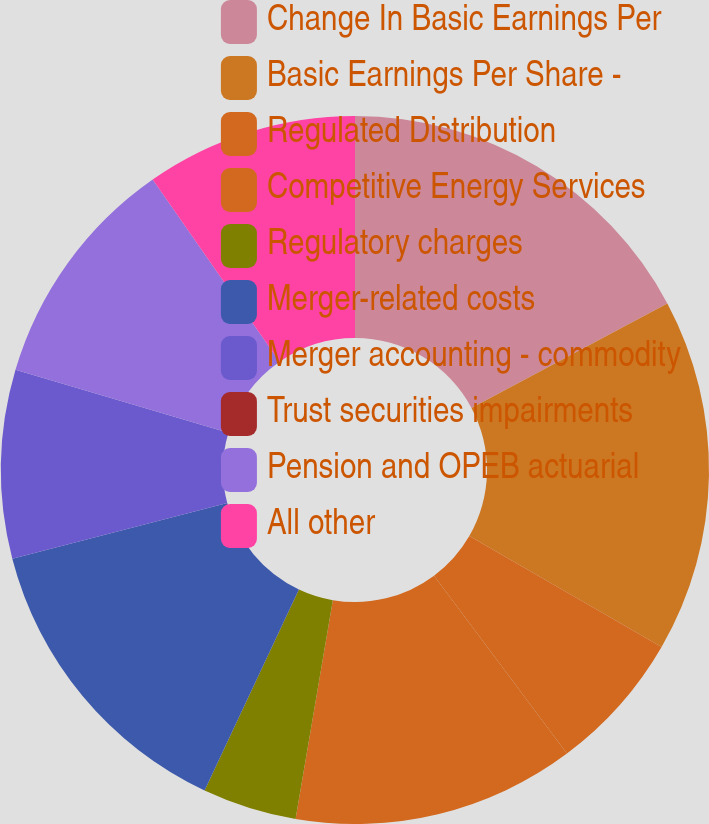Convert chart. <chart><loc_0><loc_0><loc_500><loc_500><pie_chart><fcel>Change In Basic Earnings Per<fcel>Basic Earnings Per Share -<fcel>Regulated Distribution<fcel>Competitive Energy Services<fcel>Regulatory charges<fcel>Merger-related costs<fcel>Merger accounting - commodity<fcel>Trust securities impairments<fcel>Pension and OPEB actuarial<fcel>All other<nl><fcel>17.2%<fcel>16.13%<fcel>6.45%<fcel>12.9%<fcel>4.3%<fcel>13.98%<fcel>8.6%<fcel>0.0%<fcel>10.75%<fcel>9.68%<nl></chart> 